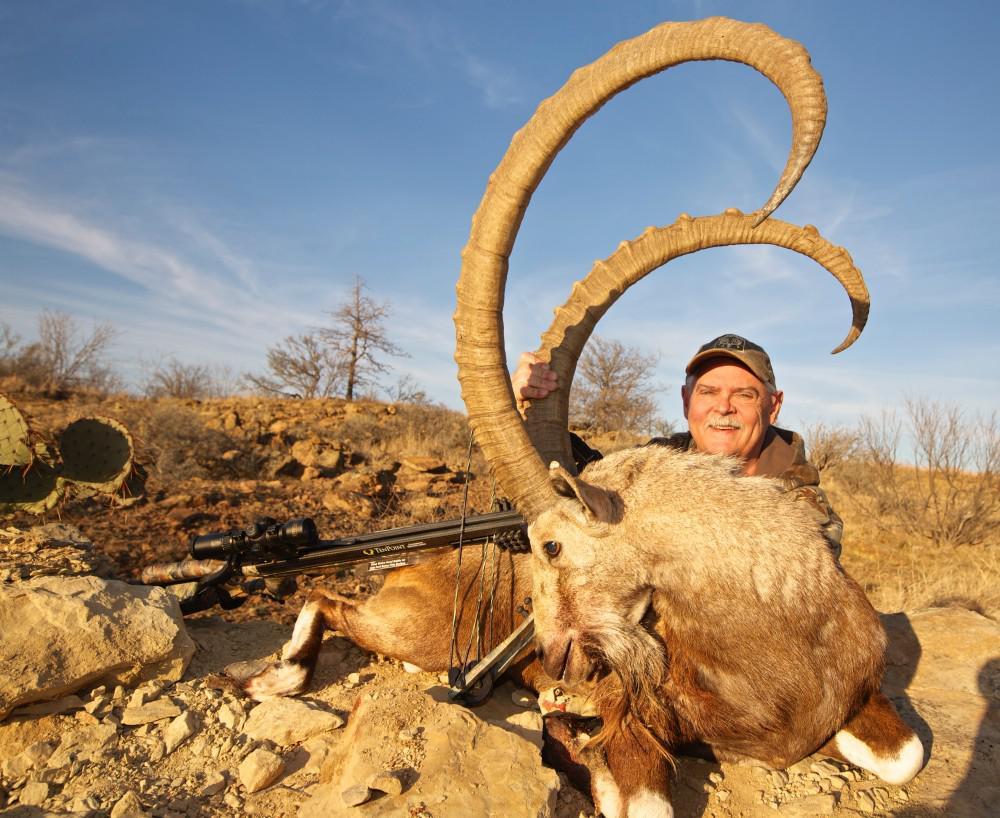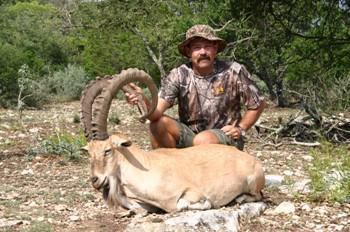The first image is the image on the left, the second image is the image on the right. Assess this claim about the two images: "In one of the images there is one man holding a rifle and posing in front of a large ram.". Correct or not? Answer yes or no. No. The first image is the image on the left, the second image is the image on the right. Given the left and right images, does the statement "There are two hunters with two horned animals." hold true? Answer yes or no. Yes. 